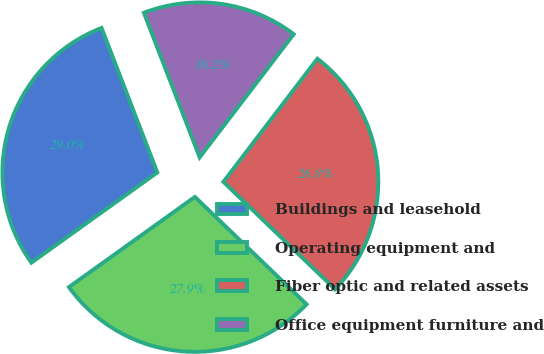<chart> <loc_0><loc_0><loc_500><loc_500><pie_chart><fcel>Buildings and leasehold<fcel>Operating equipment and<fcel>Fiber optic and related assets<fcel>Office equipment furniture and<nl><fcel>29.03%<fcel>27.92%<fcel>26.81%<fcel>16.24%<nl></chart> 